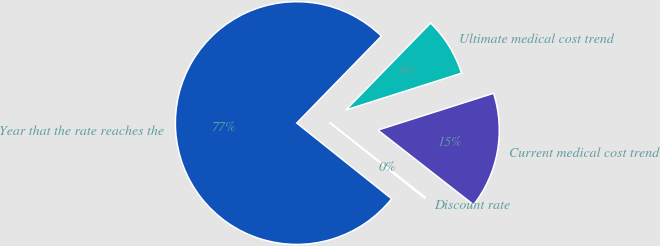<chart> <loc_0><loc_0><loc_500><loc_500><pie_chart><fcel>Discount rate<fcel>Current medical cost trend<fcel>Ultimate medical cost trend<fcel>Year that the rate reaches the<nl><fcel>0.17%<fcel>15.45%<fcel>7.81%<fcel>76.57%<nl></chart> 